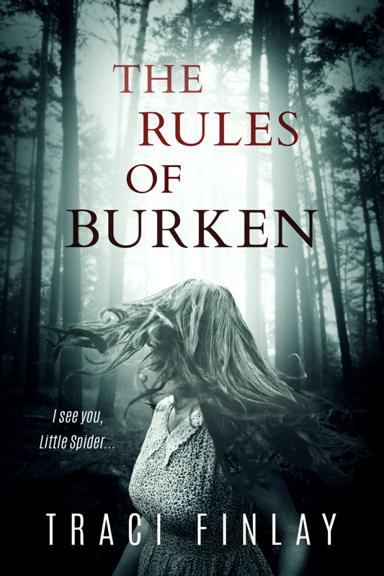What is the quote mentioned in the image? The quote visible in the image is 'I see you, Little Spider.' This intriguing sentence, featured prominently on the book cover along with a mysterious and eerie backdrop, evokes a sense of suspense and curiosity about the contents of the story. 